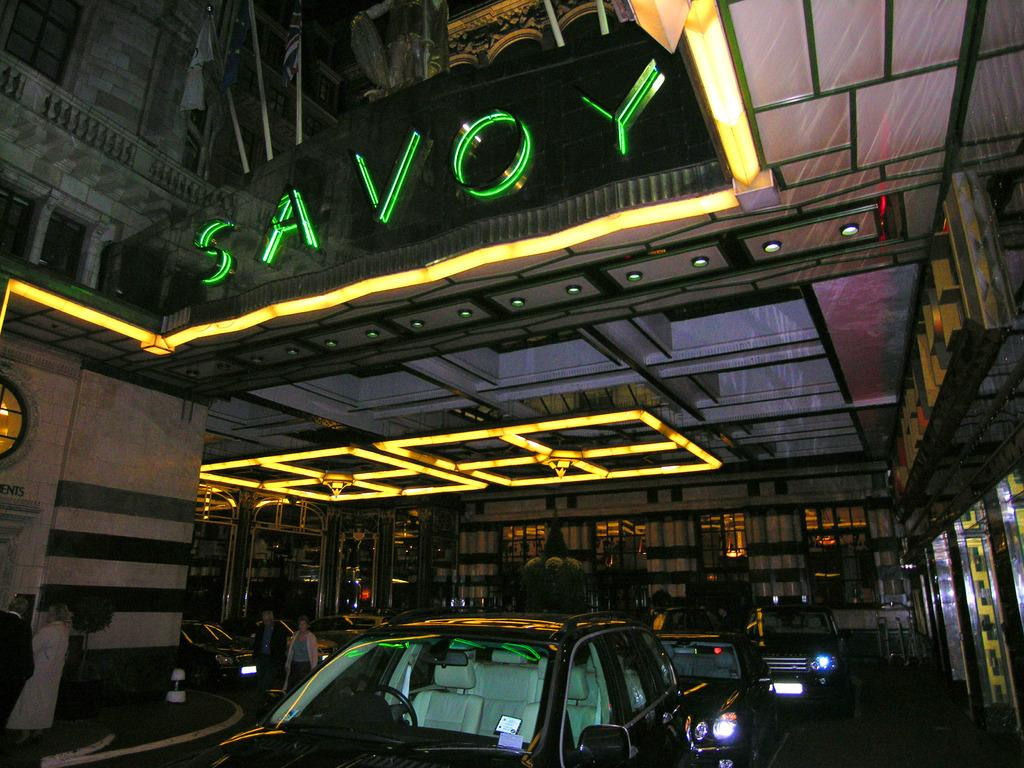<image>
Describe the image concisely. A neon sign in green that reads SAVOY. 